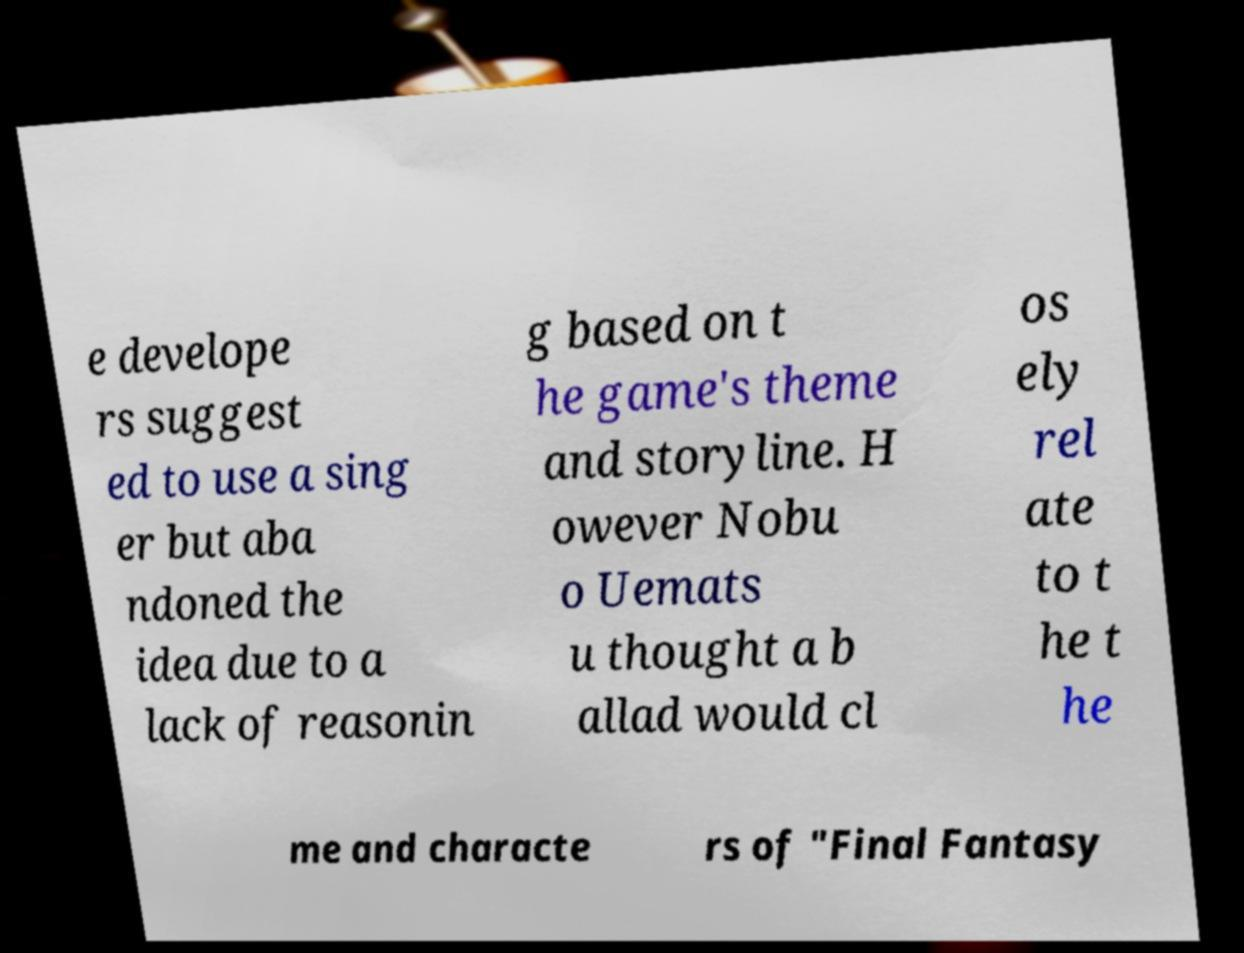Can you accurately transcribe the text from the provided image for me? e develope rs suggest ed to use a sing er but aba ndoned the idea due to a lack of reasonin g based on t he game's theme and storyline. H owever Nobu o Uemats u thought a b allad would cl os ely rel ate to t he t he me and characte rs of "Final Fantasy 